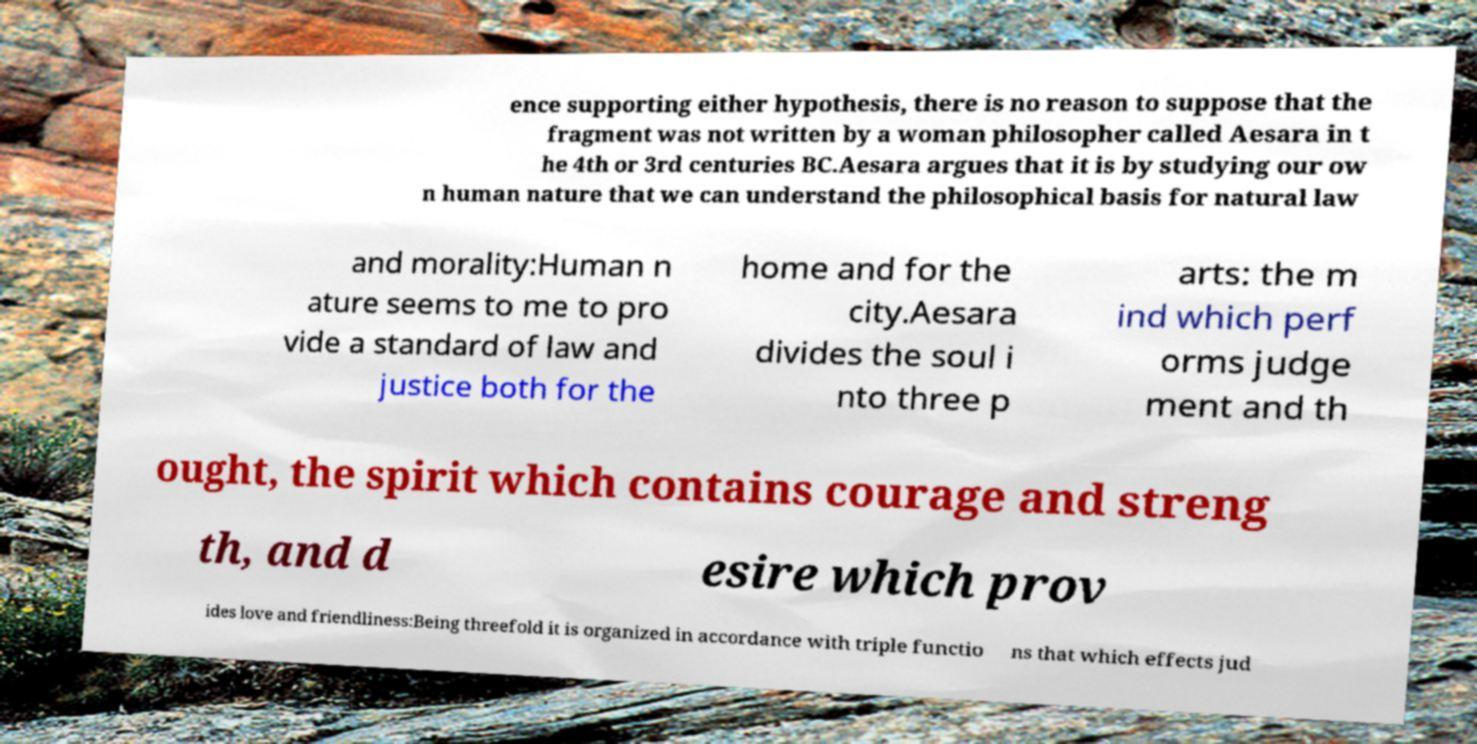Could you assist in decoding the text presented in this image and type it out clearly? ence supporting either hypothesis, there is no reason to suppose that the fragment was not written by a woman philosopher called Aesara in t he 4th or 3rd centuries BC.Aesara argues that it is by studying our ow n human nature that we can understand the philosophical basis for natural law and morality:Human n ature seems to me to pro vide a standard of law and justice both for the home and for the city.Aesara divides the soul i nto three p arts: the m ind which perf orms judge ment and th ought, the spirit which contains courage and streng th, and d esire which prov ides love and friendliness:Being threefold it is organized in accordance with triple functio ns that which effects jud 